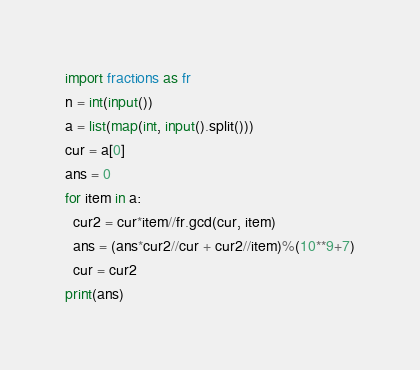Convert code to text. <code><loc_0><loc_0><loc_500><loc_500><_Python_>import fractions as fr
n = int(input())
a = list(map(int, input().split()))
cur = a[0]
ans = 0
for item in a:
  cur2 = cur*item//fr.gcd(cur, item)
  ans = (ans*cur2//cur + cur2//item)%(10**9+7)
  cur = cur2
print(ans)</code> 